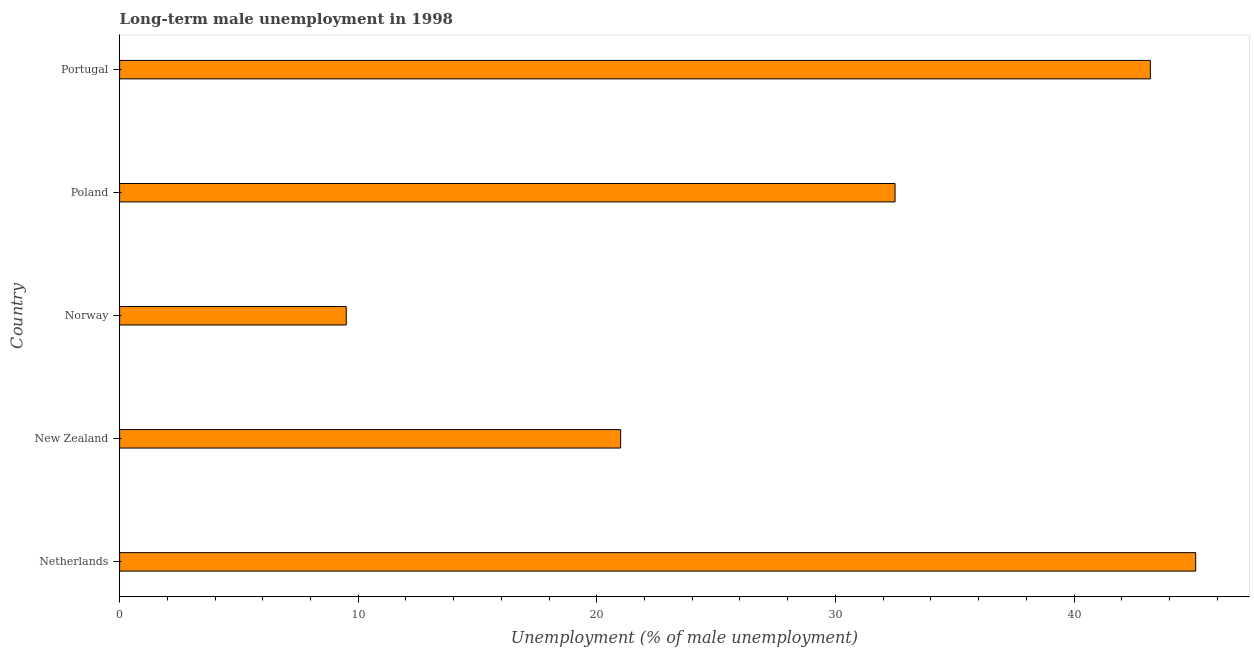What is the title of the graph?
Keep it short and to the point. Long-term male unemployment in 1998. What is the label or title of the X-axis?
Make the answer very short. Unemployment (% of male unemployment). What is the long-term male unemployment in Portugal?
Your response must be concise. 43.2. Across all countries, what is the maximum long-term male unemployment?
Make the answer very short. 45.1. Across all countries, what is the minimum long-term male unemployment?
Keep it short and to the point. 9.5. In which country was the long-term male unemployment maximum?
Offer a very short reply. Netherlands. In which country was the long-term male unemployment minimum?
Provide a short and direct response. Norway. What is the sum of the long-term male unemployment?
Offer a very short reply. 151.3. What is the average long-term male unemployment per country?
Your answer should be very brief. 30.26. What is the median long-term male unemployment?
Your answer should be compact. 32.5. What is the ratio of the long-term male unemployment in Netherlands to that in Portugal?
Your answer should be compact. 1.04. Is the sum of the long-term male unemployment in Netherlands and Portugal greater than the maximum long-term male unemployment across all countries?
Offer a very short reply. Yes. What is the difference between the highest and the lowest long-term male unemployment?
Provide a short and direct response. 35.6. Are all the bars in the graph horizontal?
Your response must be concise. Yes. What is the Unemployment (% of male unemployment) of Netherlands?
Your answer should be compact. 45.1. What is the Unemployment (% of male unemployment) of Poland?
Your answer should be very brief. 32.5. What is the Unemployment (% of male unemployment) of Portugal?
Make the answer very short. 43.2. What is the difference between the Unemployment (% of male unemployment) in Netherlands and New Zealand?
Ensure brevity in your answer.  24.1. What is the difference between the Unemployment (% of male unemployment) in Netherlands and Norway?
Your response must be concise. 35.6. What is the difference between the Unemployment (% of male unemployment) in Netherlands and Poland?
Your answer should be compact. 12.6. What is the difference between the Unemployment (% of male unemployment) in New Zealand and Norway?
Offer a terse response. 11.5. What is the difference between the Unemployment (% of male unemployment) in New Zealand and Poland?
Provide a short and direct response. -11.5. What is the difference between the Unemployment (% of male unemployment) in New Zealand and Portugal?
Keep it short and to the point. -22.2. What is the difference between the Unemployment (% of male unemployment) in Norway and Poland?
Your answer should be very brief. -23. What is the difference between the Unemployment (% of male unemployment) in Norway and Portugal?
Offer a very short reply. -33.7. What is the ratio of the Unemployment (% of male unemployment) in Netherlands to that in New Zealand?
Keep it short and to the point. 2.15. What is the ratio of the Unemployment (% of male unemployment) in Netherlands to that in Norway?
Ensure brevity in your answer.  4.75. What is the ratio of the Unemployment (% of male unemployment) in Netherlands to that in Poland?
Provide a short and direct response. 1.39. What is the ratio of the Unemployment (% of male unemployment) in Netherlands to that in Portugal?
Keep it short and to the point. 1.04. What is the ratio of the Unemployment (% of male unemployment) in New Zealand to that in Norway?
Provide a succinct answer. 2.21. What is the ratio of the Unemployment (% of male unemployment) in New Zealand to that in Poland?
Your answer should be very brief. 0.65. What is the ratio of the Unemployment (% of male unemployment) in New Zealand to that in Portugal?
Provide a short and direct response. 0.49. What is the ratio of the Unemployment (% of male unemployment) in Norway to that in Poland?
Give a very brief answer. 0.29. What is the ratio of the Unemployment (% of male unemployment) in Norway to that in Portugal?
Make the answer very short. 0.22. What is the ratio of the Unemployment (% of male unemployment) in Poland to that in Portugal?
Offer a very short reply. 0.75. 